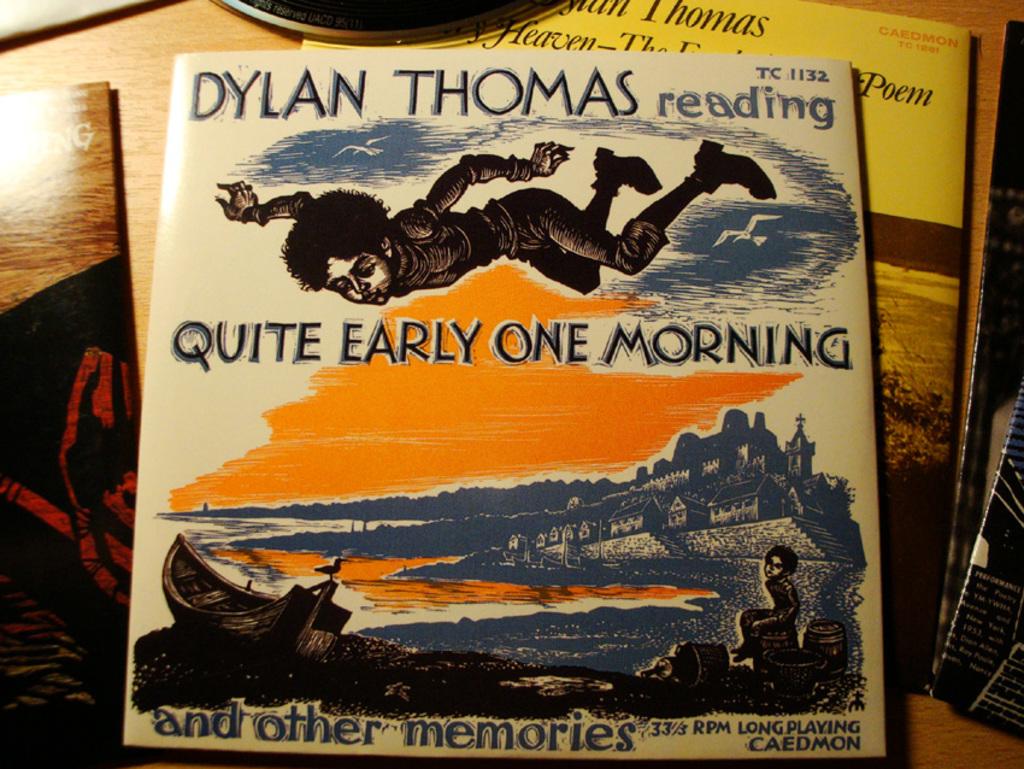Who wrote that book?
Keep it short and to the point. Dylan thomas. 